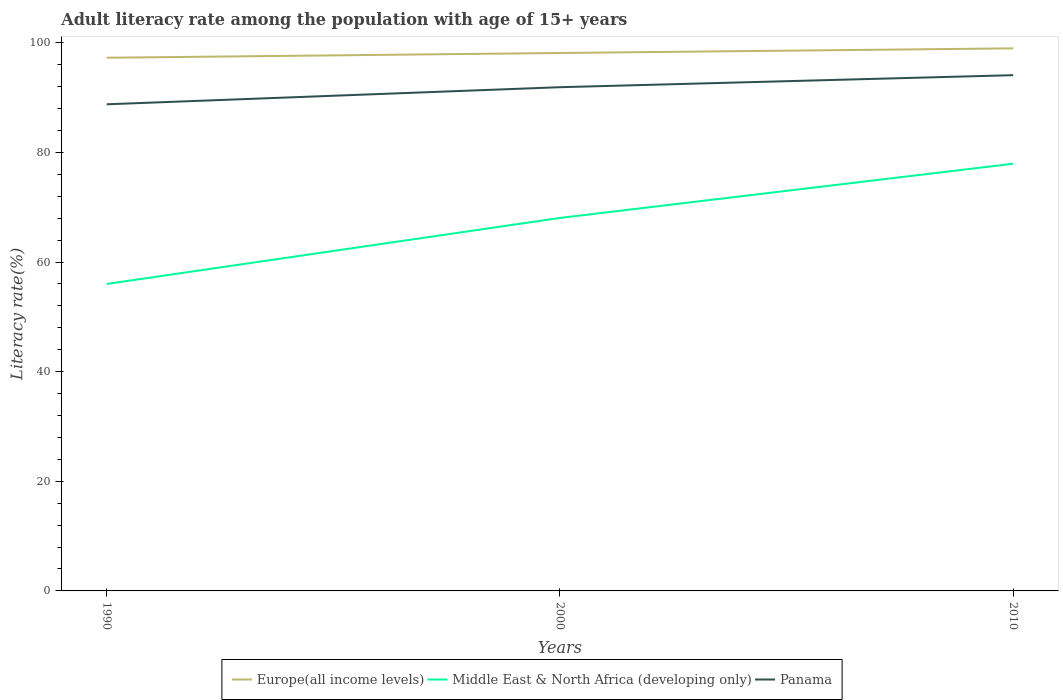Across all years, what is the maximum adult literacy rate in Panama?
Offer a very short reply. 88.78. What is the total adult literacy rate in Europe(all income levels) in the graph?
Make the answer very short. -1.71. What is the difference between the highest and the second highest adult literacy rate in Middle East & North Africa (developing only)?
Provide a short and direct response. 21.93. Is the adult literacy rate in Middle East & North Africa (developing only) strictly greater than the adult literacy rate in Panama over the years?
Your answer should be very brief. Yes. How many lines are there?
Your response must be concise. 3. Are the values on the major ticks of Y-axis written in scientific E-notation?
Your answer should be compact. No. Does the graph contain any zero values?
Ensure brevity in your answer.  No. Does the graph contain grids?
Offer a very short reply. No. Where does the legend appear in the graph?
Your answer should be very brief. Bottom center. How many legend labels are there?
Your answer should be compact. 3. How are the legend labels stacked?
Your response must be concise. Horizontal. What is the title of the graph?
Give a very brief answer. Adult literacy rate among the population with age of 15+ years. Does "Algeria" appear as one of the legend labels in the graph?
Provide a succinct answer. No. What is the label or title of the Y-axis?
Offer a very short reply. Literacy rate(%). What is the Literacy rate(%) in Europe(all income levels) in 1990?
Keep it short and to the point. 97.27. What is the Literacy rate(%) of Middle East & North Africa (developing only) in 1990?
Offer a terse response. 56.01. What is the Literacy rate(%) of Panama in 1990?
Give a very brief answer. 88.78. What is the Literacy rate(%) in Europe(all income levels) in 2000?
Offer a terse response. 98.14. What is the Literacy rate(%) in Middle East & North Africa (developing only) in 2000?
Ensure brevity in your answer.  68.05. What is the Literacy rate(%) of Panama in 2000?
Your response must be concise. 91.9. What is the Literacy rate(%) in Europe(all income levels) in 2010?
Offer a very short reply. 98.99. What is the Literacy rate(%) in Middle East & North Africa (developing only) in 2010?
Give a very brief answer. 77.94. What is the Literacy rate(%) in Panama in 2010?
Your response must be concise. 94.09. Across all years, what is the maximum Literacy rate(%) in Europe(all income levels)?
Provide a succinct answer. 98.99. Across all years, what is the maximum Literacy rate(%) in Middle East & North Africa (developing only)?
Provide a short and direct response. 77.94. Across all years, what is the maximum Literacy rate(%) in Panama?
Your answer should be very brief. 94.09. Across all years, what is the minimum Literacy rate(%) in Europe(all income levels)?
Your answer should be compact. 97.27. Across all years, what is the minimum Literacy rate(%) of Middle East & North Africa (developing only)?
Offer a terse response. 56.01. Across all years, what is the minimum Literacy rate(%) in Panama?
Provide a succinct answer. 88.78. What is the total Literacy rate(%) in Europe(all income levels) in the graph?
Offer a terse response. 294.4. What is the total Literacy rate(%) of Middle East & North Africa (developing only) in the graph?
Keep it short and to the point. 201.99. What is the total Literacy rate(%) of Panama in the graph?
Keep it short and to the point. 274.77. What is the difference between the Literacy rate(%) of Europe(all income levels) in 1990 and that in 2000?
Offer a very short reply. -0.87. What is the difference between the Literacy rate(%) of Middle East & North Africa (developing only) in 1990 and that in 2000?
Keep it short and to the point. -12.04. What is the difference between the Literacy rate(%) in Panama in 1990 and that in 2000?
Offer a terse response. -3.12. What is the difference between the Literacy rate(%) in Europe(all income levels) in 1990 and that in 2010?
Provide a short and direct response. -1.71. What is the difference between the Literacy rate(%) in Middle East & North Africa (developing only) in 1990 and that in 2010?
Your answer should be compact. -21.93. What is the difference between the Literacy rate(%) of Panama in 1990 and that in 2010?
Make the answer very short. -5.31. What is the difference between the Literacy rate(%) in Europe(all income levels) in 2000 and that in 2010?
Keep it short and to the point. -0.85. What is the difference between the Literacy rate(%) of Middle East & North Africa (developing only) in 2000 and that in 2010?
Provide a short and direct response. -9.89. What is the difference between the Literacy rate(%) of Panama in 2000 and that in 2010?
Provide a short and direct response. -2.19. What is the difference between the Literacy rate(%) in Europe(all income levels) in 1990 and the Literacy rate(%) in Middle East & North Africa (developing only) in 2000?
Your answer should be compact. 29.23. What is the difference between the Literacy rate(%) of Europe(all income levels) in 1990 and the Literacy rate(%) of Panama in 2000?
Keep it short and to the point. 5.37. What is the difference between the Literacy rate(%) of Middle East & North Africa (developing only) in 1990 and the Literacy rate(%) of Panama in 2000?
Offer a very short reply. -35.89. What is the difference between the Literacy rate(%) of Europe(all income levels) in 1990 and the Literacy rate(%) of Middle East & North Africa (developing only) in 2010?
Your answer should be very brief. 19.34. What is the difference between the Literacy rate(%) of Europe(all income levels) in 1990 and the Literacy rate(%) of Panama in 2010?
Your answer should be compact. 3.18. What is the difference between the Literacy rate(%) in Middle East & North Africa (developing only) in 1990 and the Literacy rate(%) in Panama in 2010?
Keep it short and to the point. -38.09. What is the difference between the Literacy rate(%) in Europe(all income levels) in 2000 and the Literacy rate(%) in Middle East & North Africa (developing only) in 2010?
Provide a short and direct response. 20.2. What is the difference between the Literacy rate(%) of Europe(all income levels) in 2000 and the Literacy rate(%) of Panama in 2010?
Your answer should be compact. 4.05. What is the difference between the Literacy rate(%) in Middle East & North Africa (developing only) in 2000 and the Literacy rate(%) in Panama in 2010?
Give a very brief answer. -26.05. What is the average Literacy rate(%) in Europe(all income levels) per year?
Keep it short and to the point. 98.13. What is the average Literacy rate(%) in Middle East & North Africa (developing only) per year?
Your answer should be very brief. 67.33. What is the average Literacy rate(%) of Panama per year?
Your response must be concise. 91.59. In the year 1990, what is the difference between the Literacy rate(%) in Europe(all income levels) and Literacy rate(%) in Middle East & North Africa (developing only)?
Offer a terse response. 41.27. In the year 1990, what is the difference between the Literacy rate(%) of Europe(all income levels) and Literacy rate(%) of Panama?
Keep it short and to the point. 8.49. In the year 1990, what is the difference between the Literacy rate(%) in Middle East & North Africa (developing only) and Literacy rate(%) in Panama?
Ensure brevity in your answer.  -32.77. In the year 2000, what is the difference between the Literacy rate(%) of Europe(all income levels) and Literacy rate(%) of Middle East & North Africa (developing only)?
Your answer should be compact. 30.1. In the year 2000, what is the difference between the Literacy rate(%) in Europe(all income levels) and Literacy rate(%) in Panama?
Your response must be concise. 6.24. In the year 2000, what is the difference between the Literacy rate(%) in Middle East & North Africa (developing only) and Literacy rate(%) in Panama?
Keep it short and to the point. -23.85. In the year 2010, what is the difference between the Literacy rate(%) of Europe(all income levels) and Literacy rate(%) of Middle East & North Africa (developing only)?
Your response must be concise. 21.05. In the year 2010, what is the difference between the Literacy rate(%) of Europe(all income levels) and Literacy rate(%) of Panama?
Provide a short and direct response. 4.89. In the year 2010, what is the difference between the Literacy rate(%) of Middle East & North Africa (developing only) and Literacy rate(%) of Panama?
Give a very brief answer. -16.16. What is the ratio of the Literacy rate(%) of Middle East & North Africa (developing only) in 1990 to that in 2000?
Keep it short and to the point. 0.82. What is the ratio of the Literacy rate(%) in Panama in 1990 to that in 2000?
Offer a terse response. 0.97. What is the ratio of the Literacy rate(%) of Europe(all income levels) in 1990 to that in 2010?
Your response must be concise. 0.98. What is the ratio of the Literacy rate(%) of Middle East & North Africa (developing only) in 1990 to that in 2010?
Ensure brevity in your answer.  0.72. What is the ratio of the Literacy rate(%) in Panama in 1990 to that in 2010?
Make the answer very short. 0.94. What is the ratio of the Literacy rate(%) in Middle East & North Africa (developing only) in 2000 to that in 2010?
Your response must be concise. 0.87. What is the ratio of the Literacy rate(%) in Panama in 2000 to that in 2010?
Your response must be concise. 0.98. What is the difference between the highest and the second highest Literacy rate(%) in Europe(all income levels)?
Your response must be concise. 0.85. What is the difference between the highest and the second highest Literacy rate(%) of Middle East & North Africa (developing only)?
Provide a short and direct response. 9.89. What is the difference between the highest and the second highest Literacy rate(%) of Panama?
Your answer should be compact. 2.19. What is the difference between the highest and the lowest Literacy rate(%) of Europe(all income levels)?
Your answer should be very brief. 1.71. What is the difference between the highest and the lowest Literacy rate(%) in Middle East & North Africa (developing only)?
Keep it short and to the point. 21.93. What is the difference between the highest and the lowest Literacy rate(%) of Panama?
Ensure brevity in your answer.  5.31. 